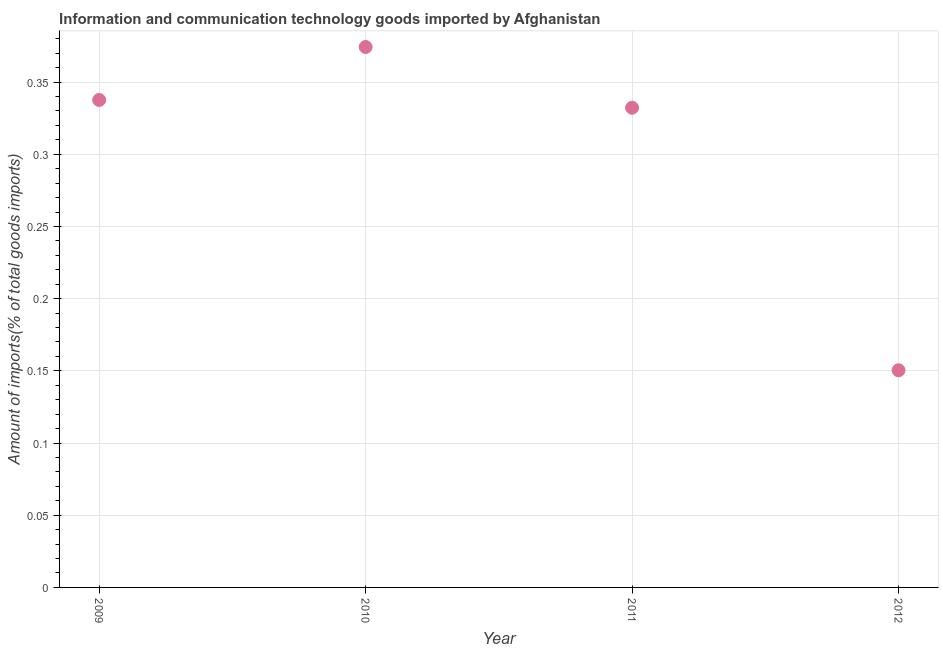What is the amount of ict goods imports in 2012?
Provide a short and direct response. 0.15. Across all years, what is the maximum amount of ict goods imports?
Give a very brief answer. 0.37. Across all years, what is the minimum amount of ict goods imports?
Provide a short and direct response. 0.15. In which year was the amount of ict goods imports minimum?
Make the answer very short. 2012. What is the sum of the amount of ict goods imports?
Keep it short and to the point. 1.19. What is the difference between the amount of ict goods imports in 2010 and 2012?
Ensure brevity in your answer.  0.22. What is the average amount of ict goods imports per year?
Your response must be concise. 0.3. What is the median amount of ict goods imports?
Keep it short and to the point. 0.33. Do a majority of the years between 2012 and 2011 (inclusive) have amount of ict goods imports greater than 0.32000000000000006 %?
Your answer should be very brief. No. What is the ratio of the amount of ict goods imports in 2009 to that in 2011?
Offer a very short reply. 1.02. Is the amount of ict goods imports in 2009 less than that in 2012?
Your response must be concise. No. Is the difference between the amount of ict goods imports in 2009 and 2012 greater than the difference between any two years?
Provide a short and direct response. No. What is the difference between the highest and the second highest amount of ict goods imports?
Offer a terse response. 0.04. Is the sum of the amount of ict goods imports in 2009 and 2010 greater than the maximum amount of ict goods imports across all years?
Your answer should be very brief. Yes. What is the difference between the highest and the lowest amount of ict goods imports?
Make the answer very short. 0.22. In how many years, is the amount of ict goods imports greater than the average amount of ict goods imports taken over all years?
Your response must be concise. 3. Does the amount of ict goods imports monotonically increase over the years?
Ensure brevity in your answer.  No. What is the difference between two consecutive major ticks on the Y-axis?
Give a very brief answer. 0.05. Does the graph contain any zero values?
Your answer should be very brief. No. What is the title of the graph?
Make the answer very short. Information and communication technology goods imported by Afghanistan. What is the label or title of the Y-axis?
Keep it short and to the point. Amount of imports(% of total goods imports). What is the Amount of imports(% of total goods imports) in 2009?
Offer a very short reply. 0.34. What is the Amount of imports(% of total goods imports) in 2010?
Give a very brief answer. 0.37. What is the Amount of imports(% of total goods imports) in 2011?
Ensure brevity in your answer.  0.33. What is the Amount of imports(% of total goods imports) in 2012?
Offer a terse response. 0.15. What is the difference between the Amount of imports(% of total goods imports) in 2009 and 2010?
Provide a short and direct response. -0.04. What is the difference between the Amount of imports(% of total goods imports) in 2009 and 2011?
Offer a very short reply. 0.01. What is the difference between the Amount of imports(% of total goods imports) in 2009 and 2012?
Offer a terse response. 0.19. What is the difference between the Amount of imports(% of total goods imports) in 2010 and 2011?
Make the answer very short. 0.04. What is the difference between the Amount of imports(% of total goods imports) in 2010 and 2012?
Provide a short and direct response. 0.22. What is the difference between the Amount of imports(% of total goods imports) in 2011 and 2012?
Offer a very short reply. 0.18. What is the ratio of the Amount of imports(% of total goods imports) in 2009 to that in 2010?
Provide a short and direct response. 0.9. What is the ratio of the Amount of imports(% of total goods imports) in 2009 to that in 2011?
Your answer should be compact. 1.02. What is the ratio of the Amount of imports(% of total goods imports) in 2009 to that in 2012?
Keep it short and to the point. 2.25. What is the ratio of the Amount of imports(% of total goods imports) in 2010 to that in 2011?
Ensure brevity in your answer.  1.13. What is the ratio of the Amount of imports(% of total goods imports) in 2010 to that in 2012?
Keep it short and to the point. 2.49. What is the ratio of the Amount of imports(% of total goods imports) in 2011 to that in 2012?
Your response must be concise. 2.21. 